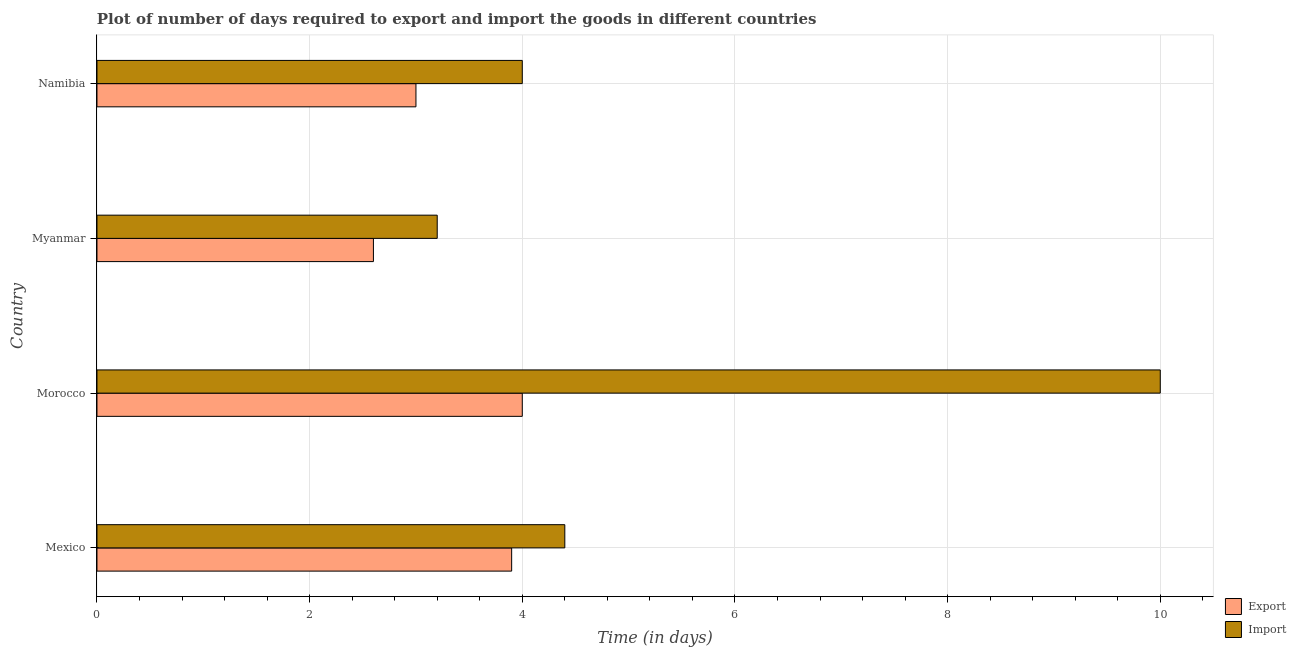How many different coloured bars are there?
Offer a very short reply. 2. How many bars are there on the 4th tick from the top?
Provide a succinct answer. 2. How many bars are there on the 1st tick from the bottom?
Offer a very short reply. 2. What is the label of the 1st group of bars from the top?
Provide a short and direct response. Namibia. What is the time required to import in Mexico?
Ensure brevity in your answer.  4.4. Across all countries, what is the minimum time required to export?
Offer a very short reply. 2.6. In which country was the time required to import maximum?
Give a very brief answer. Morocco. In which country was the time required to import minimum?
Offer a very short reply. Myanmar. What is the difference between the time required to export in Mexico and that in Myanmar?
Ensure brevity in your answer.  1.3. What is the difference between the time required to export in Mexico and the time required to import in Namibia?
Your response must be concise. -0.1. What is the average time required to import per country?
Offer a very short reply. 5.4. What is the ratio of the time required to import in Mexico to that in Namibia?
Offer a very short reply. 1.1. What is the difference between the highest and the second highest time required to import?
Provide a short and direct response. 5.6. In how many countries, is the time required to export greater than the average time required to export taken over all countries?
Ensure brevity in your answer.  2. What does the 1st bar from the top in Myanmar represents?
Your answer should be compact. Import. What does the 2nd bar from the bottom in Morocco represents?
Your answer should be very brief. Import. How many bars are there?
Give a very brief answer. 8. How many countries are there in the graph?
Ensure brevity in your answer.  4. What is the difference between two consecutive major ticks on the X-axis?
Your response must be concise. 2. Where does the legend appear in the graph?
Offer a terse response. Bottom right. How many legend labels are there?
Keep it short and to the point. 2. What is the title of the graph?
Your answer should be compact. Plot of number of days required to export and import the goods in different countries. Does "Secondary Education" appear as one of the legend labels in the graph?
Provide a short and direct response. No. What is the label or title of the X-axis?
Your answer should be very brief. Time (in days). What is the Time (in days) of Export in Mexico?
Offer a very short reply. 3.9. What is the Time (in days) in Import in Mexico?
Offer a terse response. 4.4. What is the Time (in days) in Import in Myanmar?
Offer a terse response. 3.2. What is the Time (in days) of Import in Namibia?
Give a very brief answer. 4. Across all countries, what is the minimum Time (in days) of Import?
Provide a succinct answer. 3.2. What is the total Time (in days) in Export in the graph?
Offer a terse response. 13.5. What is the total Time (in days) in Import in the graph?
Keep it short and to the point. 21.6. What is the difference between the Time (in days) of Import in Mexico and that in Morocco?
Your answer should be compact. -5.6. What is the difference between the Time (in days) in Export in Mexico and that in Myanmar?
Your answer should be compact. 1.3. What is the difference between the Time (in days) of Export in Mexico and that in Namibia?
Provide a short and direct response. 0.9. What is the difference between the Time (in days) in Import in Mexico and that in Namibia?
Your answer should be compact. 0.4. What is the difference between the Time (in days) of Export in Morocco and that in Myanmar?
Your answer should be compact. 1.4. What is the difference between the Time (in days) of Import in Morocco and that in Namibia?
Your answer should be compact. 6. What is the difference between the Time (in days) in Export in Myanmar and that in Namibia?
Your answer should be compact. -0.4. What is the difference between the Time (in days) in Import in Myanmar and that in Namibia?
Make the answer very short. -0.8. What is the difference between the Time (in days) in Export in Mexico and the Time (in days) in Import in Morocco?
Give a very brief answer. -6.1. What is the difference between the Time (in days) in Export in Mexico and the Time (in days) in Import in Namibia?
Keep it short and to the point. -0.1. What is the difference between the Time (in days) in Export in Morocco and the Time (in days) in Import in Namibia?
Ensure brevity in your answer.  0. What is the average Time (in days) in Export per country?
Your answer should be compact. 3.38. What is the difference between the Time (in days) in Export and Time (in days) in Import in Namibia?
Your answer should be very brief. -1. What is the ratio of the Time (in days) of Import in Mexico to that in Morocco?
Ensure brevity in your answer.  0.44. What is the ratio of the Time (in days) of Export in Mexico to that in Myanmar?
Provide a succinct answer. 1.5. What is the ratio of the Time (in days) of Import in Mexico to that in Myanmar?
Make the answer very short. 1.38. What is the ratio of the Time (in days) of Export in Morocco to that in Myanmar?
Ensure brevity in your answer.  1.54. What is the ratio of the Time (in days) in Import in Morocco to that in Myanmar?
Make the answer very short. 3.12. What is the ratio of the Time (in days) of Export in Morocco to that in Namibia?
Provide a succinct answer. 1.33. What is the ratio of the Time (in days) of Import in Morocco to that in Namibia?
Make the answer very short. 2.5. What is the ratio of the Time (in days) of Export in Myanmar to that in Namibia?
Your answer should be compact. 0.87. What is the difference between the highest and the second highest Time (in days) in Export?
Provide a succinct answer. 0.1. What is the difference between the highest and the lowest Time (in days) in Export?
Provide a short and direct response. 1.4. What is the difference between the highest and the lowest Time (in days) in Import?
Give a very brief answer. 6.8. 